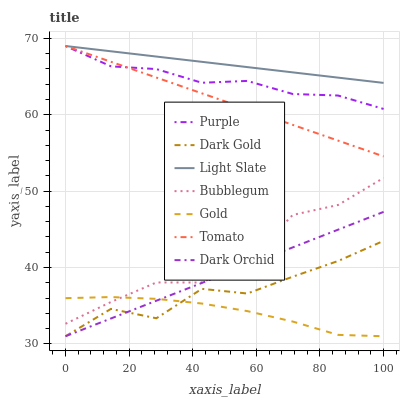Does Gold have the minimum area under the curve?
Answer yes or no. Yes. Does Light Slate have the maximum area under the curve?
Answer yes or no. Yes. Does Dark Gold have the minimum area under the curve?
Answer yes or no. No. Does Dark Gold have the maximum area under the curve?
Answer yes or no. No. Is Light Slate the smoothest?
Answer yes or no. Yes. Is Dark Gold the roughest?
Answer yes or no. Yes. Is Gold the smoothest?
Answer yes or no. No. Is Gold the roughest?
Answer yes or no. No. Does Purple have the lowest value?
Answer yes or no. No. Does Light Slate have the highest value?
Answer yes or no. Yes. Does Dark Gold have the highest value?
Answer yes or no. No. Is Dark Gold less than Light Slate?
Answer yes or no. Yes. Is Light Slate greater than Gold?
Answer yes or no. Yes. Does Dark Gold intersect Light Slate?
Answer yes or no. No. 